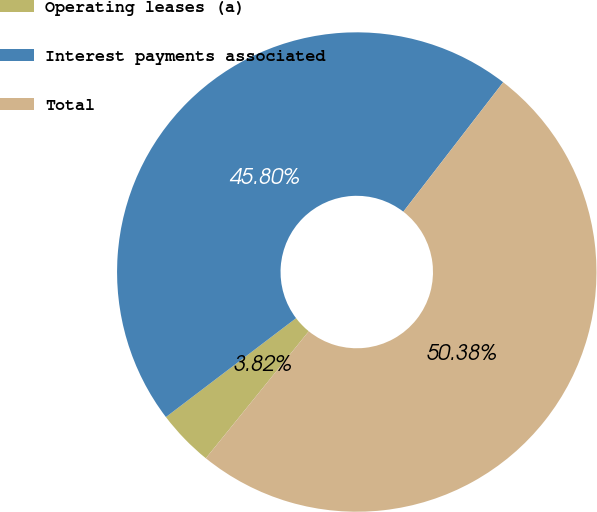<chart> <loc_0><loc_0><loc_500><loc_500><pie_chart><fcel>Operating leases (a)<fcel>Interest payments associated<fcel>Total<nl><fcel>3.82%<fcel>45.8%<fcel>50.38%<nl></chart> 